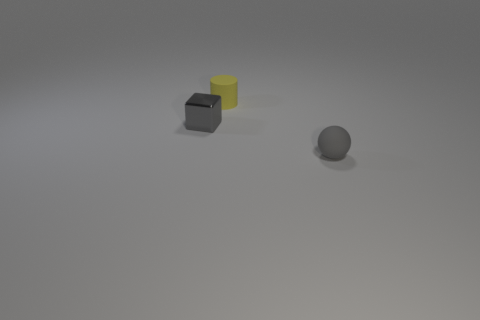There is a tiny matte thing behind the matte thing in front of the small yellow cylinder; how many gray matte balls are in front of it?
Offer a very short reply. 1. Do the gray object that is behind the tiny matte ball and the tiny yellow matte thing have the same shape?
Offer a terse response. No. How many things are big gray matte cubes or rubber things behind the tiny gray matte sphere?
Offer a terse response. 1. Is the number of gray metal things to the right of the block greater than the number of tiny yellow cylinders?
Your response must be concise. No. Are there the same number of gray blocks that are behind the metal block and tiny rubber things in front of the yellow cylinder?
Give a very brief answer. No. Are there any small balls that are in front of the small object right of the yellow thing?
Your response must be concise. No. What is the shape of the gray rubber object?
Give a very brief answer. Sphere. What size is the thing that is the same color as the ball?
Provide a succinct answer. Small. There is a gray object that is left of the tiny thing that is in front of the small metal cube; what size is it?
Provide a short and direct response. Small. What size is the rubber thing behind the gray rubber sphere?
Make the answer very short. Small. 